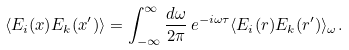<formula> <loc_0><loc_0><loc_500><loc_500>\langle E _ { i } ( x ) E _ { k } ( x ^ { \prime } ) \rangle = \int _ { - \infty } ^ { \infty } \frac { d \omega } { 2 \pi } \, e ^ { - i \omega \tau } \langle E _ { i } ( { r } ) E _ { k } ( { r ^ { \prime } } ) \rangle _ { \omega } .</formula> 